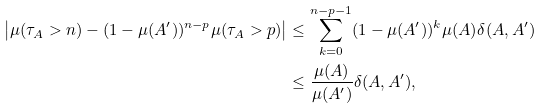Convert formula to latex. <formula><loc_0><loc_0><loc_500><loc_500>\left | \mu ( \tau _ { A } > n ) - ( 1 - \mu ( A ^ { \prime } ) ) ^ { n - p } \mu ( \tau _ { A } > p ) \right | & \leq \sum _ { k = 0 } ^ { n - p - 1 } ( 1 - \mu ( A ^ { \prime } ) ) ^ { k } \mu ( A ) \delta ( A , A ^ { \prime } ) \\ & \leq \frac { \mu ( A ) } { \mu ( A ^ { \prime } ) } \delta ( A , A ^ { \prime } ) ,</formula> 